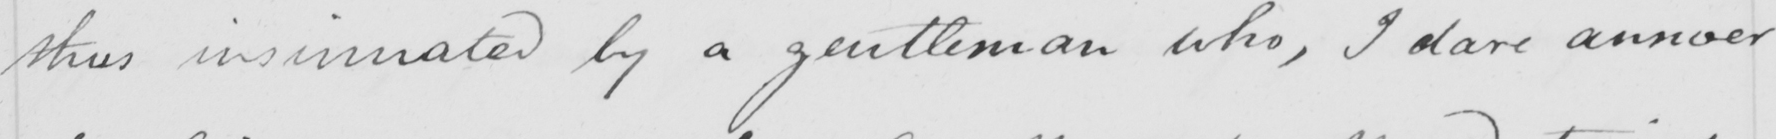Can you read and transcribe this handwriting? thus insinuated by a gentleman who , I dare answer 